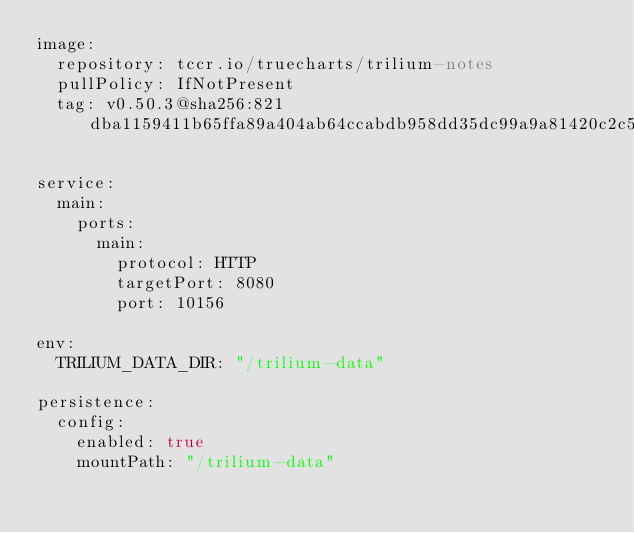<code> <loc_0><loc_0><loc_500><loc_500><_YAML_>image:
  repository: tccr.io/truecharts/trilium-notes
  pullPolicy: IfNotPresent
  tag: v0.50.3@sha256:821dba1159411b65ffa89a404ab64ccabdb958dd35dc99a9a81420c2c5980012

service:
  main:
    ports:
      main:
        protocol: HTTP
        targetPort: 8080
        port: 10156

env:
  TRILIUM_DATA_DIR: "/trilium-data"

persistence:
  config:
    enabled: true
    mountPath: "/trilium-data"
</code> 